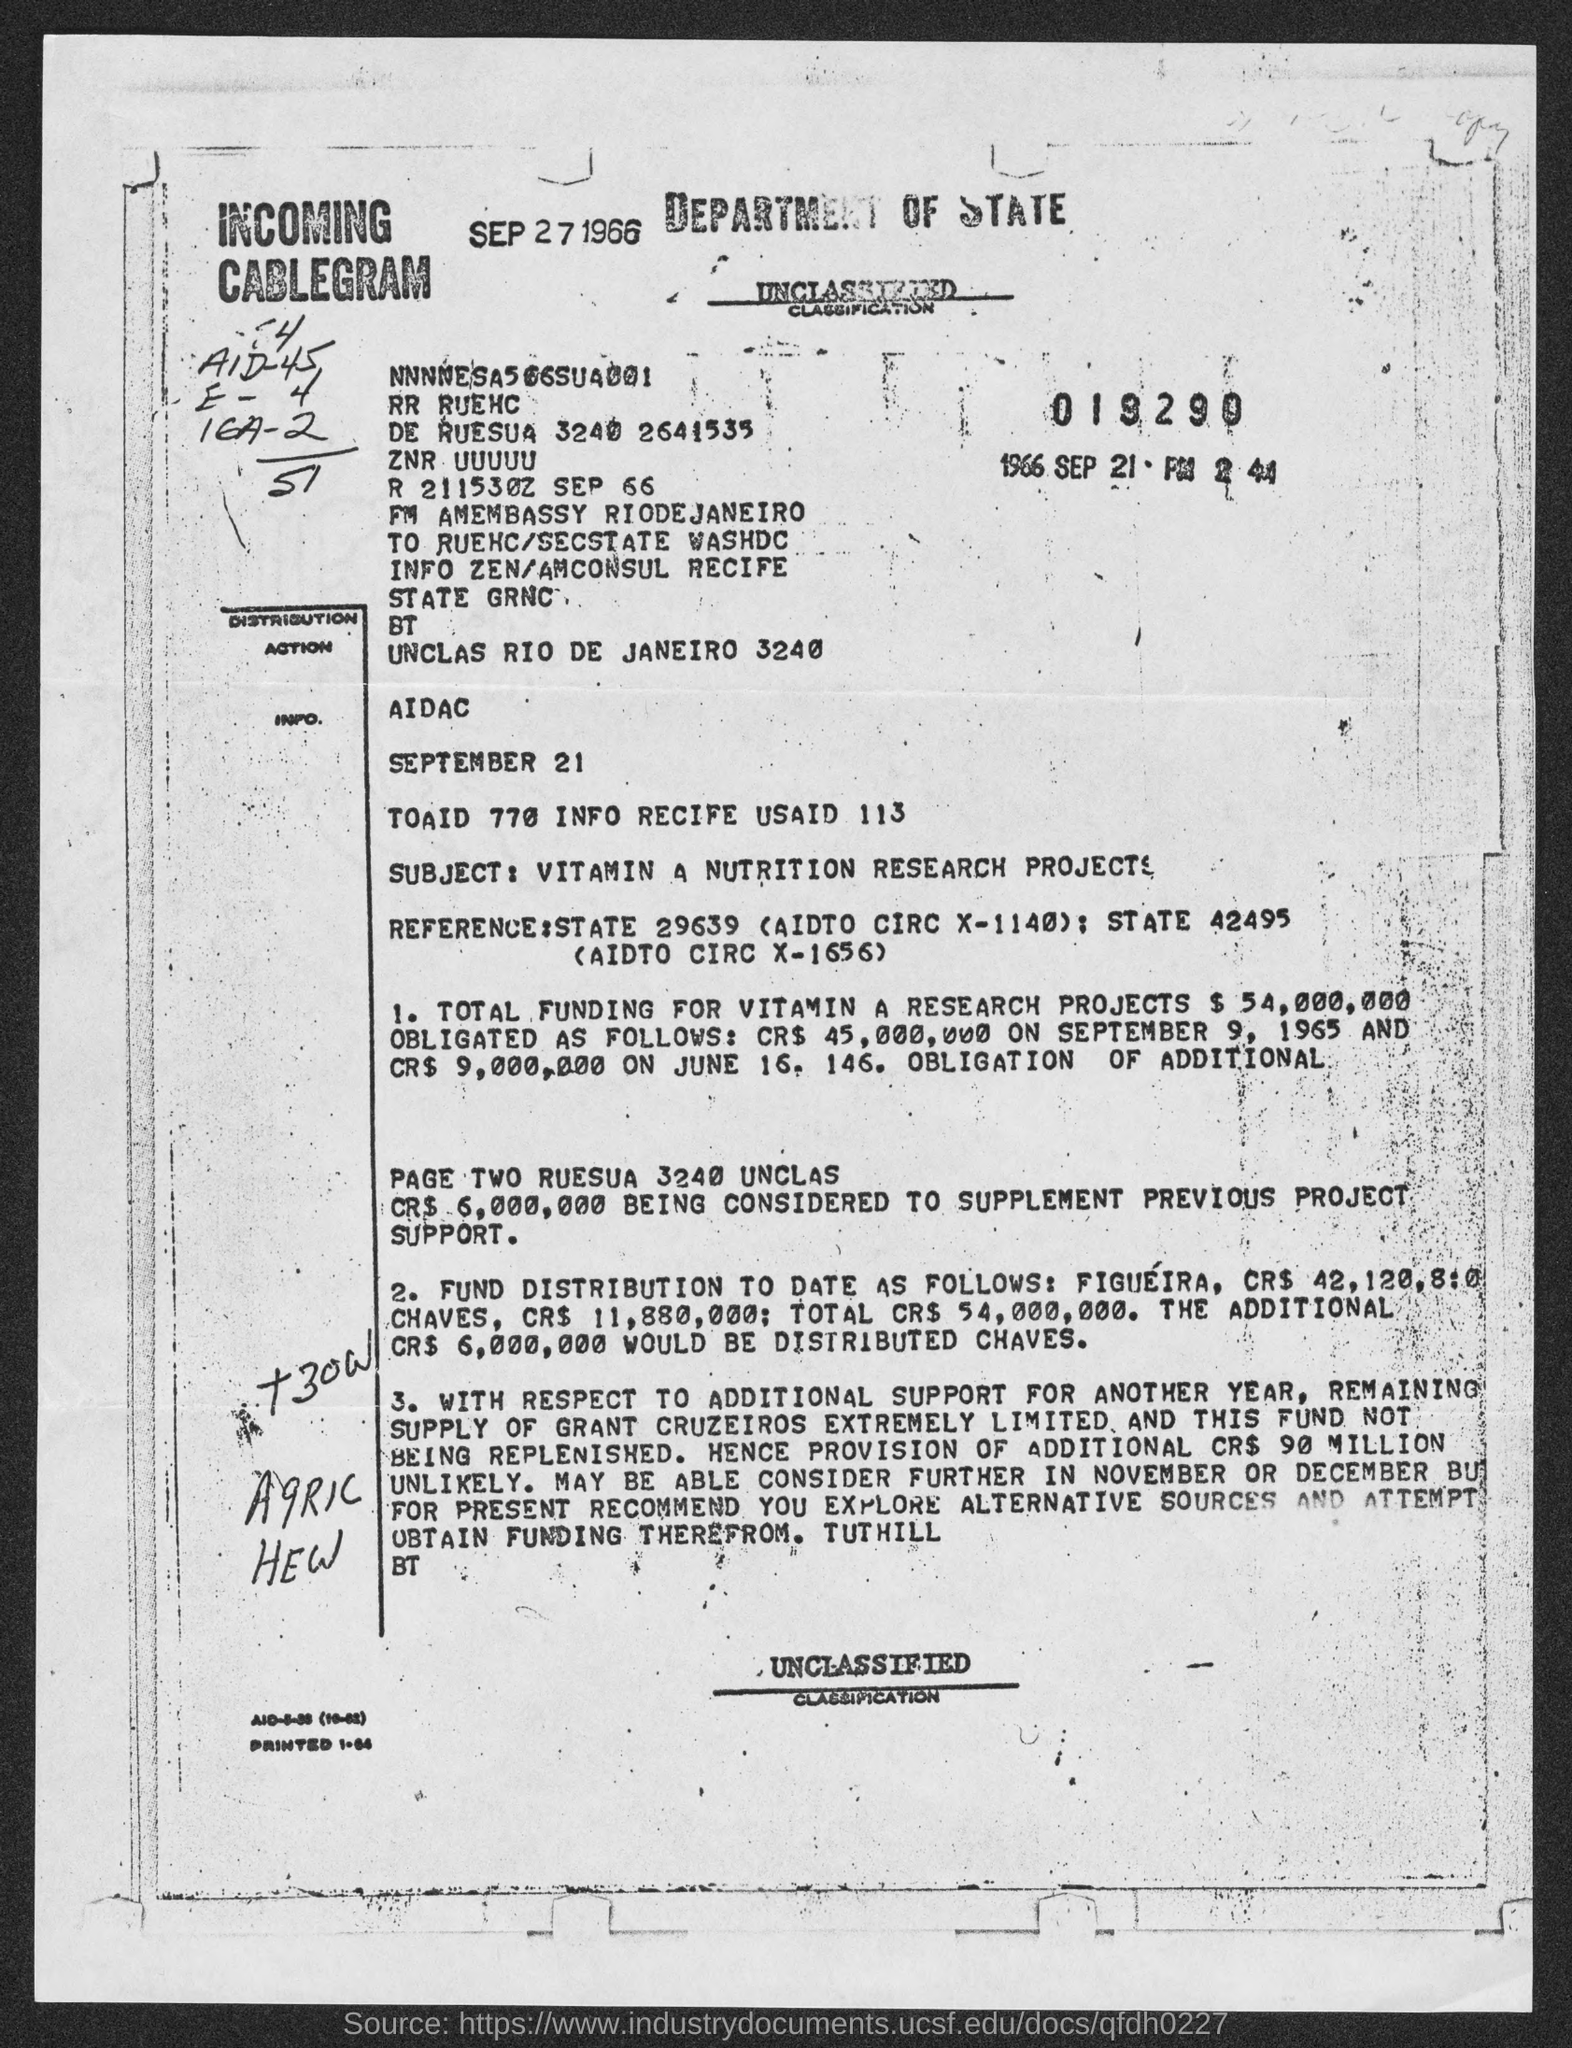What is the Subject of this document ?
Provide a succinct answer. Vitamin A Nutrition research Projects. 